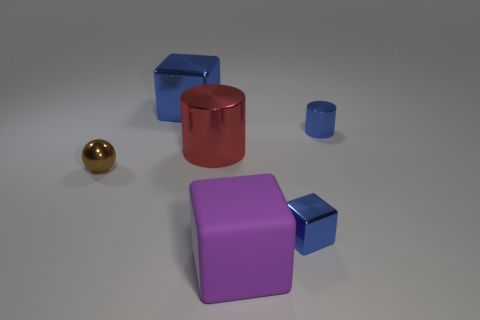Add 3 tiny green matte objects. How many objects exist? 9 Subtract all spheres. How many objects are left? 5 Subtract all brown matte things. Subtract all blue metal cylinders. How many objects are left? 5 Add 2 large metallic objects. How many large metallic objects are left? 4 Add 5 red cylinders. How many red cylinders exist? 6 Subtract 1 blue blocks. How many objects are left? 5 